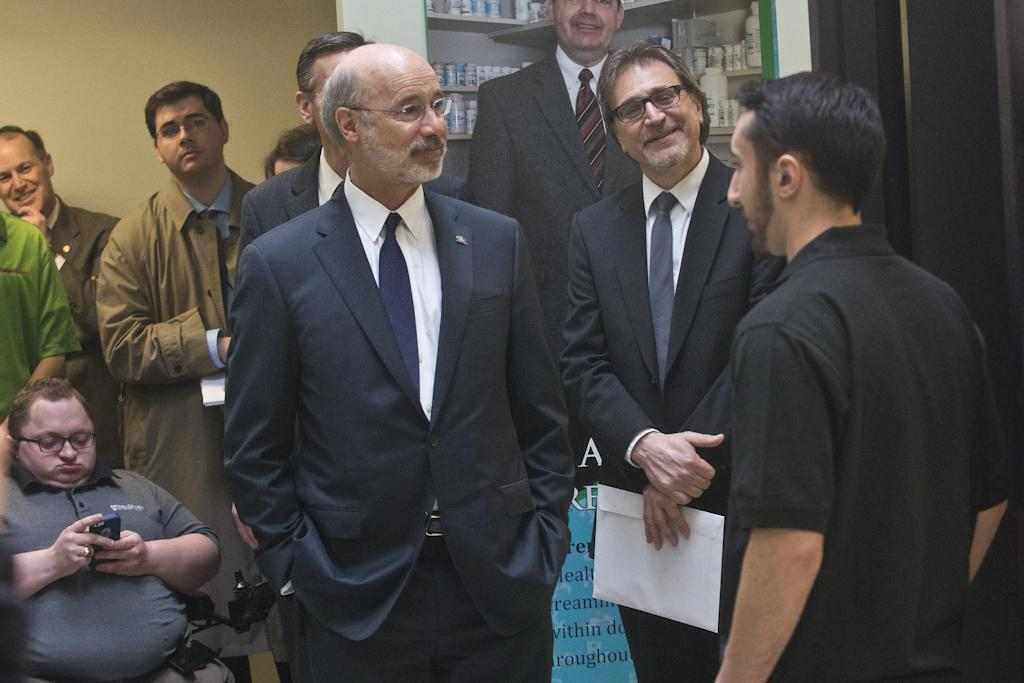What can be seen in the image involving human subjects? There are people standing in the image. Where are the people standing? The people are standing on the floor. What else can be seen on the shelves in the image? There are bottles on a shelf in the image. What is visible behind the people and shelves? There is a wall visible in the image. What type of stick is being used by the people in the image? There is no stick visible in the image; the people are simply standing on the floor. 